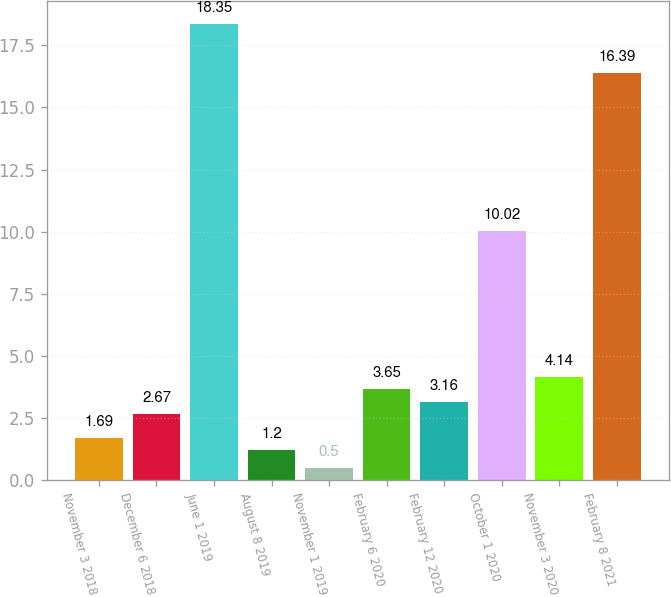Convert chart to OTSL. <chart><loc_0><loc_0><loc_500><loc_500><bar_chart><fcel>November 3 2018<fcel>December 6 2018<fcel>June 1 2019<fcel>August 8 2019<fcel>November 1 2019<fcel>February 6 2020<fcel>February 12 2020<fcel>October 1 2020<fcel>November 3 2020<fcel>February 8 2021<nl><fcel>1.69<fcel>2.67<fcel>18.35<fcel>1.2<fcel>0.5<fcel>3.65<fcel>3.16<fcel>10.02<fcel>4.14<fcel>16.39<nl></chart> 